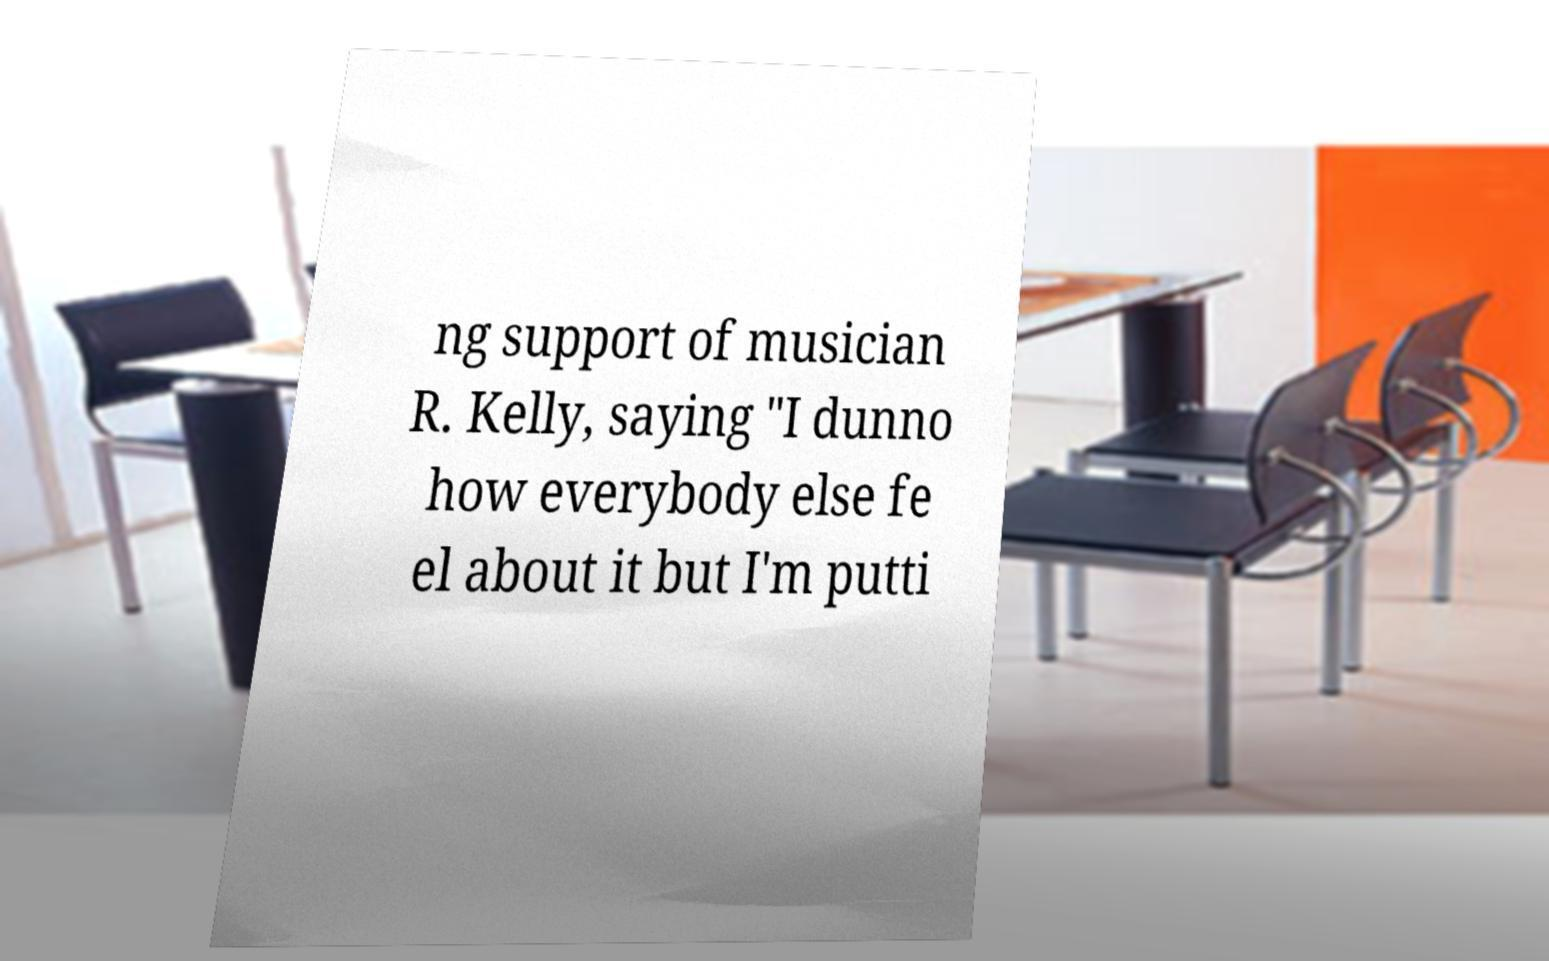Please identify and transcribe the text found in this image. ng support of musician R. Kelly, saying "I dunno how everybody else fe el about it but I'm putti 